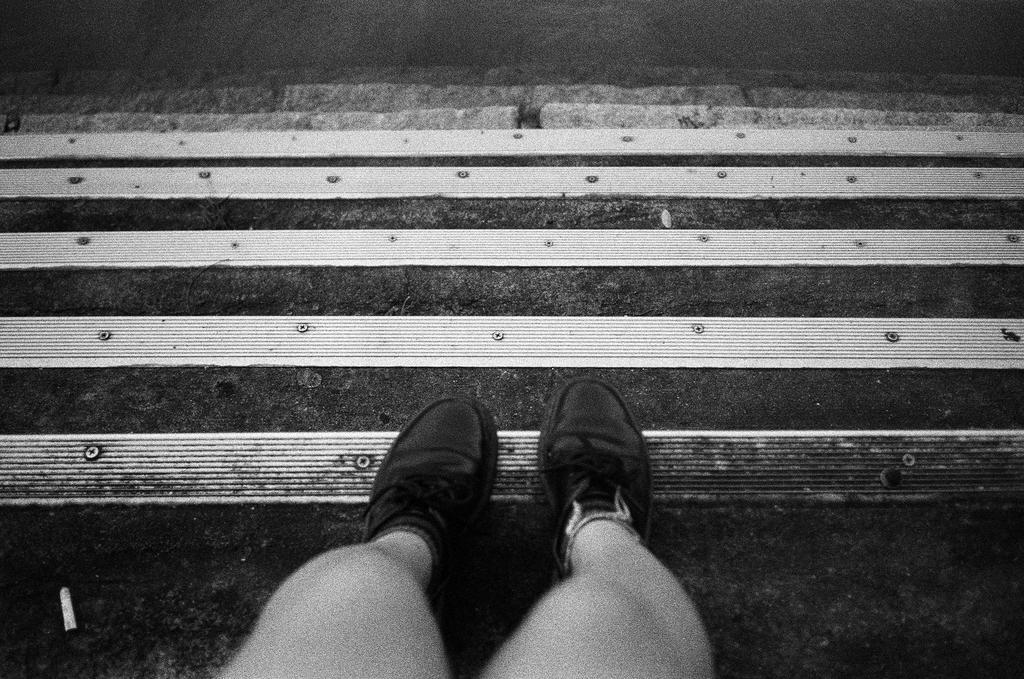Could you give a brief overview of what you see in this image? This is black and white picture, in this picture we can see person's legs with footwear and we can see steps. 